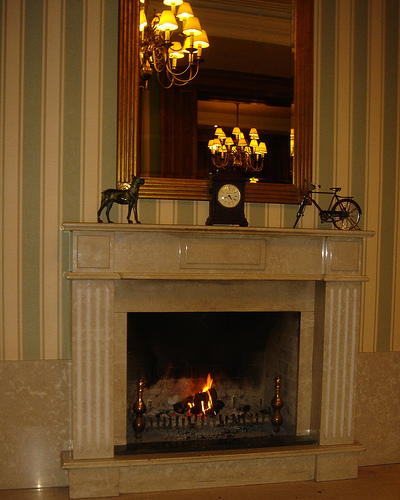<image>
Is there a clock on the wall? No. The clock is not positioned on the wall. They may be near each other, but the clock is not supported by or resting on top of the wall. 